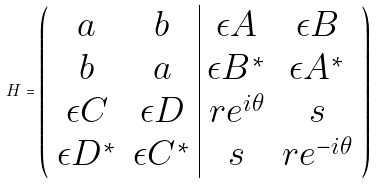<formula> <loc_0><loc_0><loc_500><loc_500>H = \left ( \begin{array} { c c | c c } a & b & \epsilon A & \epsilon B \\ b & a & \epsilon B ^ { * } & \epsilon A ^ { * } \\ \epsilon C & \epsilon D & r e ^ { i \theta } & s \\ \epsilon D ^ { * } & \epsilon C ^ { * } & s & r e ^ { - i \theta } \\ \end{array} \right )</formula> 